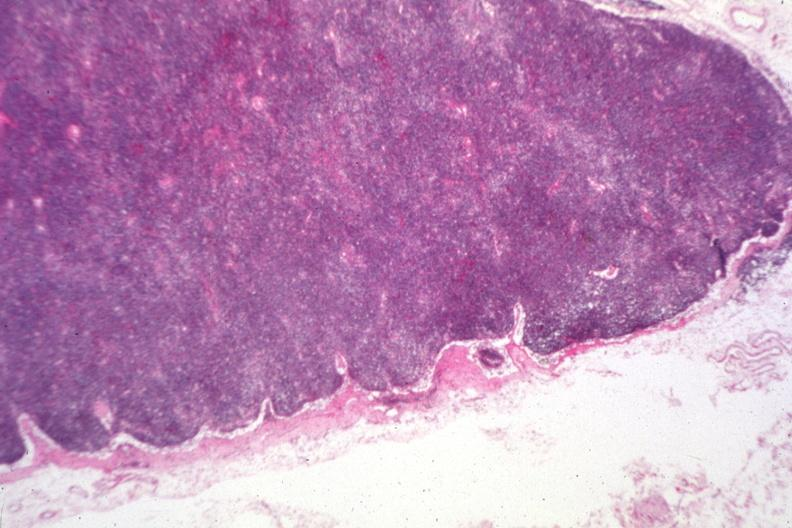what is present?
Answer the question using a single word or phrase. Chronic lymphocytic leukemia 